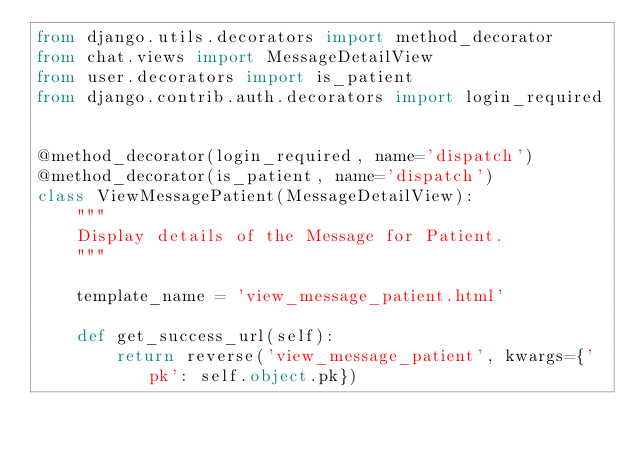Convert code to text. <code><loc_0><loc_0><loc_500><loc_500><_Python_>from django.utils.decorators import method_decorator
from chat.views import MessageDetailView
from user.decorators import is_patient
from django.contrib.auth.decorators import login_required


@method_decorator(login_required, name='dispatch')
@method_decorator(is_patient, name='dispatch')
class ViewMessagePatient(MessageDetailView):
    """
    Display details of the Message for Patient.
    """

    template_name = 'view_message_patient.html'

    def get_success_url(self):
        return reverse('view_message_patient', kwargs={'pk': self.object.pk})
</code> 